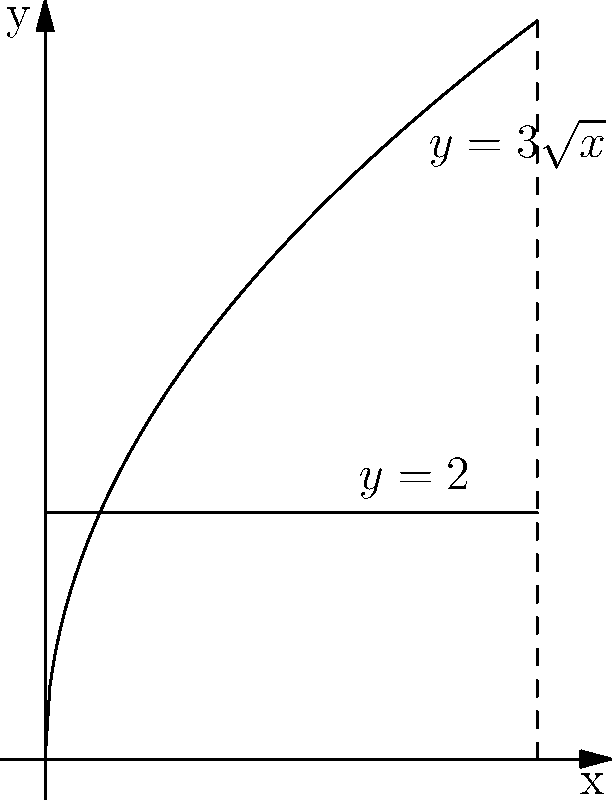As a concerned Worthington local without a personal vehicle, you're interested in rainwater harvesting to reduce your environmental impact. You want to design a cylindrical water tank with a height of 4 meters and a base radius determined by the curve $y=3\sqrt{x}$ rotated around the y-axis from $y=0$ to $y=2$. Calculate the volume of this tank using the washer method. Let's approach this step-by-step:

1) The washer method for volume is given by the formula:
   $$V = \pi \int_a^b [R(y)^2 - r(y)^2] dy$$
   where $R(y)$ is the outer radius and $r(y)$ is the inner radius.

2) In this case, we're rotating around the y-axis, so we need to express x in terms of y:
   $y = 3\sqrt{x}$
   $x = (\frac{y}{3})^2$

3) The outer radius $R(y)$ is given by this function: $R(y) = (\frac{y}{3})^2$

4) The inner radius $r(y)$ is 0 since we're rotating from the y-axis.

5) Our limits of integration are from $y=0$ to $y=2$.

6) Plugging this into our volume formula:
   $$V = \pi \int_0^2 [(\frac{y}{3})^4 - 0^2] dy$$

7) Simplifying:
   $$V = \pi \int_0^2 \frac{y^4}{81} dy$$

8) Integrating:
   $$V = \pi [\frac{y^5}{405}]_0^2$$

9) Evaluating the integral:
   $$V = \pi (\frac{32}{405} - 0) = \frac{32\pi}{405}$$

10) This gives us the volume in cubic meters.
Answer: $\frac{32\pi}{405}$ cubic meters 